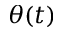Convert formula to latex. <formula><loc_0><loc_0><loc_500><loc_500>\theta ( t )</formula> 